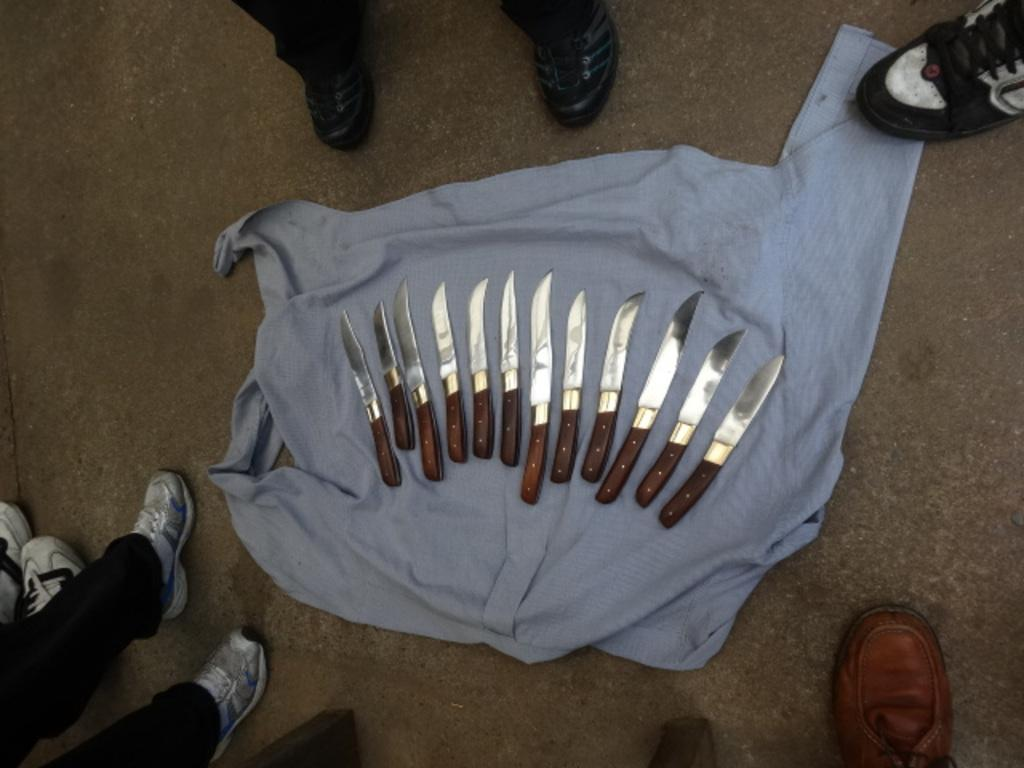What objects are on the cloth in the image? There are many knives on a cloth in the image. Where is the cloth located? The cloth is on the road. Can you see any people in the image? Yes, there are legs of multiple persons visible in the image. What is the surface at the bottom of the image? There is a road at the bottom of the image. What type of boot is being gripped by the person in the image? There is no boot or person gripping a boot present in the image; it only shows knives on a cloth and legs of multiple persons. 